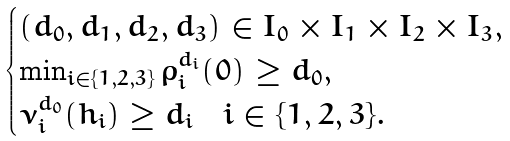Convert formula to latex. <formula><loc_0><loc_0><loc_500><loc_500>\begin{cases} ( d _ { 0 } , d _ { 1 } , d _ { 2 } , d _ { 3 } ) \in I _ { 0 } \times I _ { 1 } \times I _ { 2 } \times I _ { 3 } , \\ \min _ { i \in \{ 1 , 2 , 3 \} } \rho _ { i } ^ { d _ { i } } ( 0 ) \geq d _ { 0 } , \\ \nu _ { i } ^ { d _ { 0 } } ( h _ { i } ) \geq d _ { i } \quad i \in \{ 1 , 2 , 3 \} . \end{cases}</formula> 